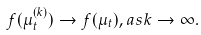Convert formula to latex. <formula><loc_0><loc_0><loc_500><loc_500>f ( \mu _ { t } ^ { ( k ) } ) \to f ( \mu _ { t } ) , a s k \to \infty .</formula> 